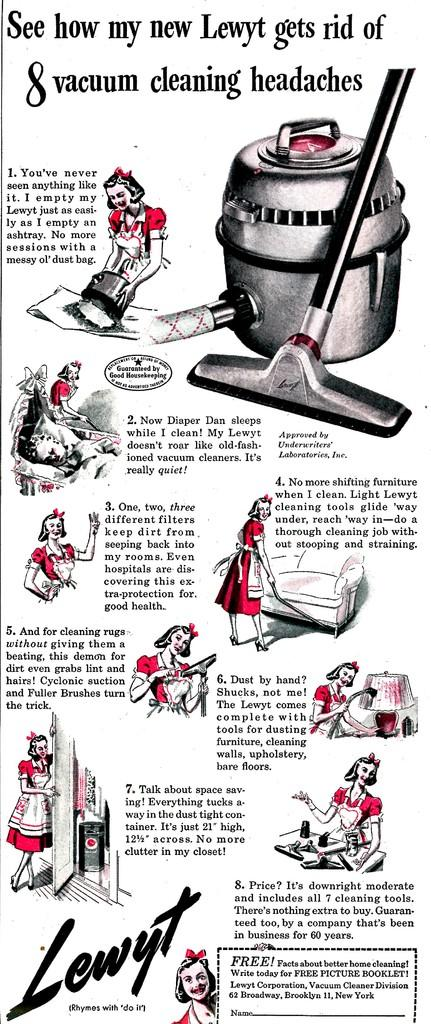<image>
Share a concise interpretation of the image provided. An advertisement for a Lewyt vacuum shows different ways it can be used. 